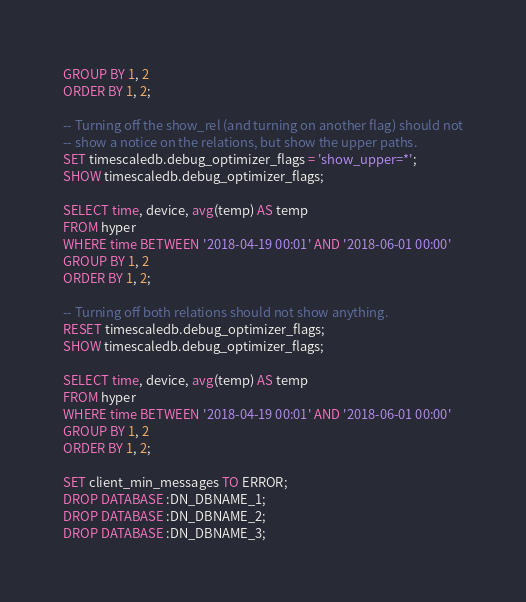Convert code to text. <code><loc_0><loc_0><loc_500><loc_500><_SQL_>GROUP BY 1, 2
ORDER BY 1, 2;

-- Turning off the show_rel (and turning on another flag) should not
-- show a notice on the relations, but show the upper paths.
SET timescaledb.debug_optimizer_flags = 'show_upper=*';
SHOW timescaledb.debug_optimizer_flags;

SELECT time, device, avg(temp) AS temp
FROM hyper
WHERE time BETWEEN '2018-04-19 00:01' AND '2018-06-01 00:00'
GROUP BY 1, 2
ORDER BY 1, 2;

-- Turning off both relations should not show anything.
RESET timescaledb.debug_optimizer_flags;
SHOW timescaledb.debug_optimizer_flags;

SELECT time, device, avg(temp) AS temp
FROM hyper
WHERE time BETWEEN '2018-04-19 00:01' AND '2018-06-01 00:00'
GROUP BY 1, 2
ORDER BY 1, 2;

SET client_min_messages TO ERROR;
DROP DATABASE :DN_DBNAME_1;
DROP DATABASE :DN_DBNAME_2;
DROP DATABASE :DN_DBNAME_3;
</code> 